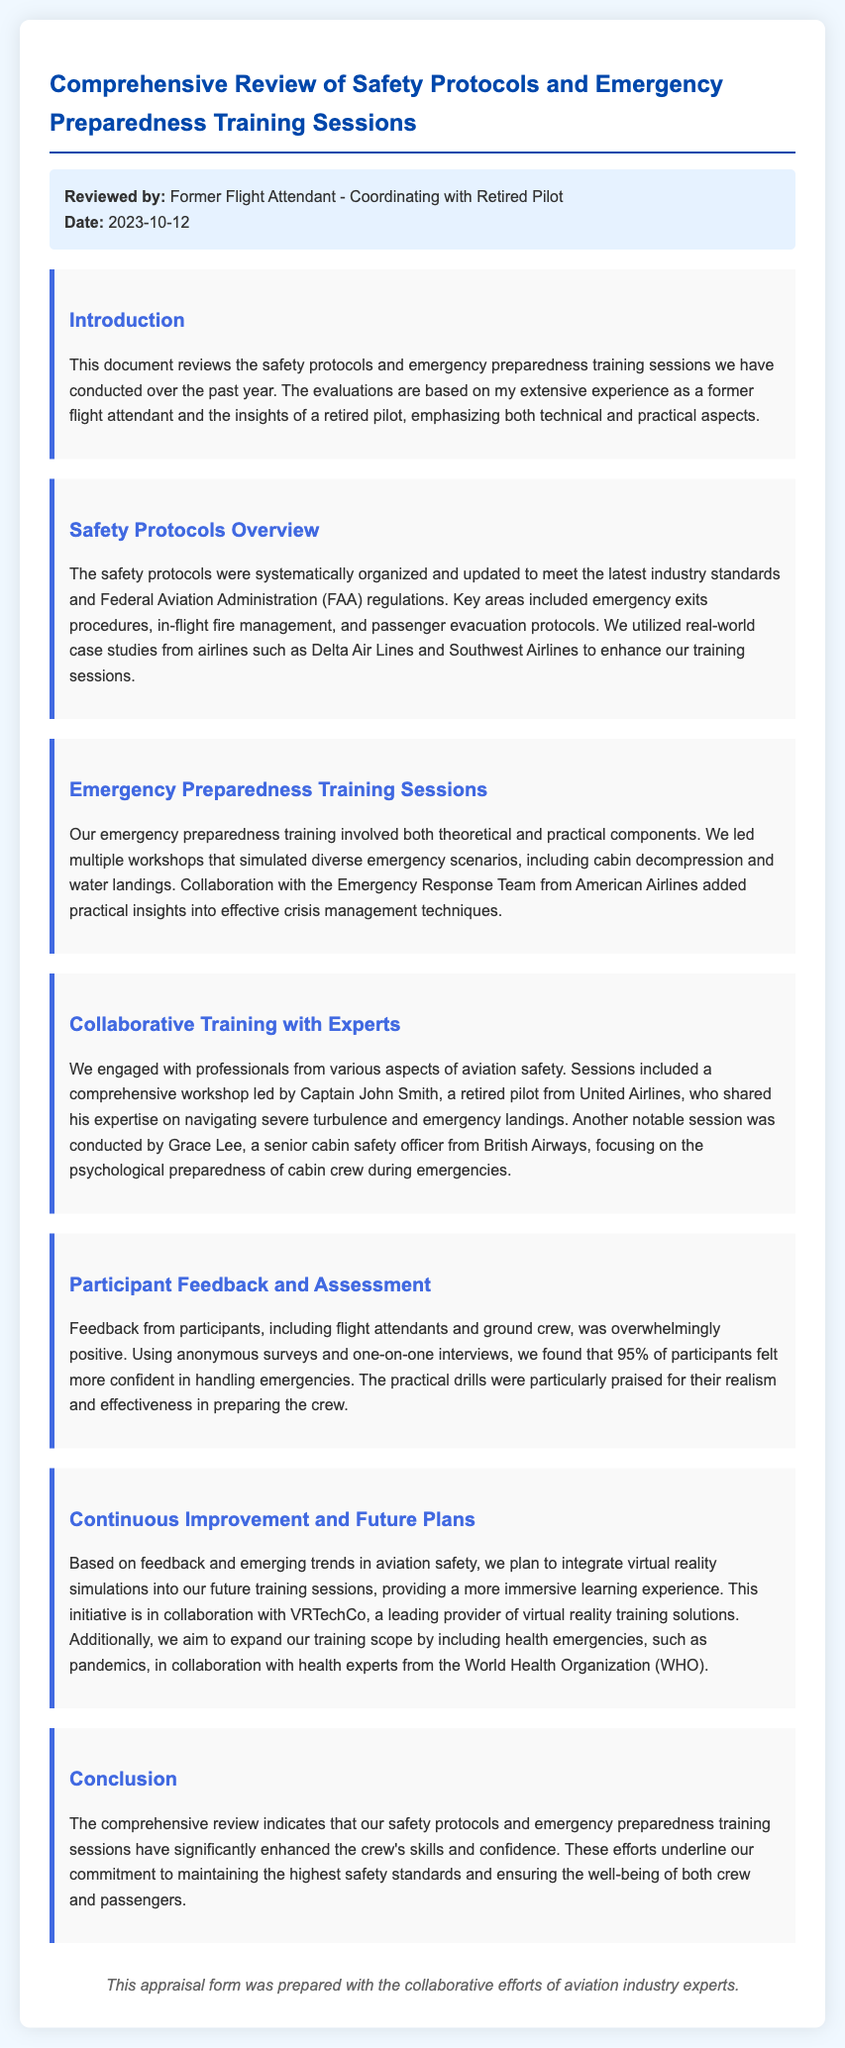what is the date of the appraisal? The date of the appraisal is listed in the document as 2023-10-12.
Answer: 2023-10-12 who reviewed the document? The document states it was reviewed by a former flight attendant in collaboration with a retired pilot.
Answer: Former Flight Attendant - Coordinating with Retired Pilot what percentage of participants felt more confident in handling emergencies? The document mentions that 95% of participants expressed increased confidence.
Answer: 95% which airline did Captain John Smith retire from? The document specifies that Captain John Smith is a retired pilot from United Airlines.
Answer: United Airlines what new technology is planned to be integrated into future training sessions? The document indicates the integration of virtual reality simulations for the upcoming training sessions.
Answer: virtual reality simulations how many workshops simulated diverse emergency scenarios? The document mentions leading multiple workshops that simulated emergency scenarios but does not specify a number.
Answer: multiple what theme was emphasized in Grace Lee's session? The session conducted by Grace Lee focused on the psychological preparedness of cabin crew during emergencies.
Answer: psychological preparedness from which organization are health experts collaborating for future training? The document states that health experts from the World Health Organization (WHO) are collaborating for future training.
Answer: World Health Organization (WHO) what is the main purpose of this document? The main purpose highlighted in the document is to review safety protocols and emergency preparedness training sessions.
Answer: review safety protocols and emergency preparedness training sessions 